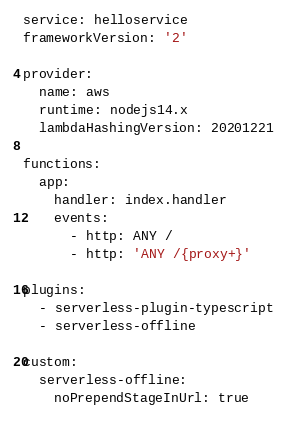<code> <loc_0><loc_0><loc_500><loc_500><_YAML_>service: helloservice
frameworkVersion: '2'

provider:
  name: aws
  runtime: nodejs14.x
  lambdaHashingVersion: 20201221

functions:
  app:
    handler: index.handler
    events:
      - http: ANY /
      - http: 'ANY /{proxy+}'

plugins:
  - serverless-plugin-typescript
  - serverless-offline

custom:
  serverless-offline:
    noPrependStageInUrl: true
</code> 